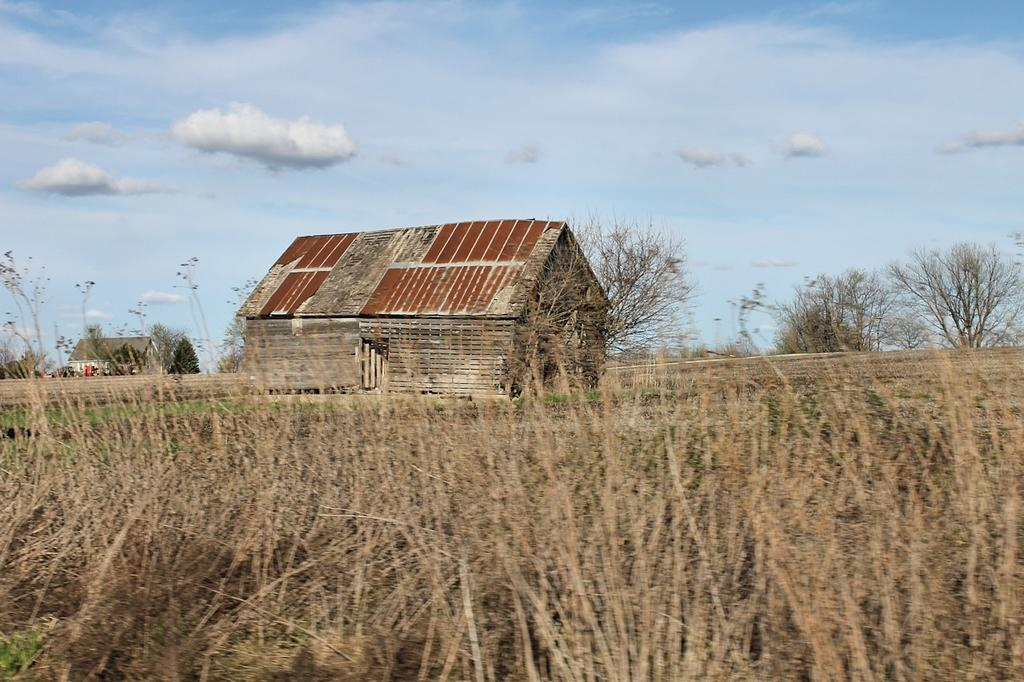How many sheds can be seen in the image? There are two sheds in the image. What other natural elements are present in the image? There are trees and plants in the image. What type of business is being conducted in the image? There is no indication of a business in the image; it primarily features sheds, trees, and plants. Can you see any chickens in the image? There are no chickens present in the image. 